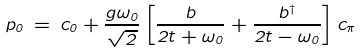<formula> <loc_0><loc_0><loc_500><loc_500>p _ { 0 } \, = \, c _ { 0 } + \frac { g \omega _ { 0 } } { \sqrt { 2 } } \left [ \frac { b } { 2 t + \omega _ { 0 } } + \frac { b ^ { \dagger } } { 2 t - \omega _ { 0 } } \right ] c _ { \pi }</formula> 